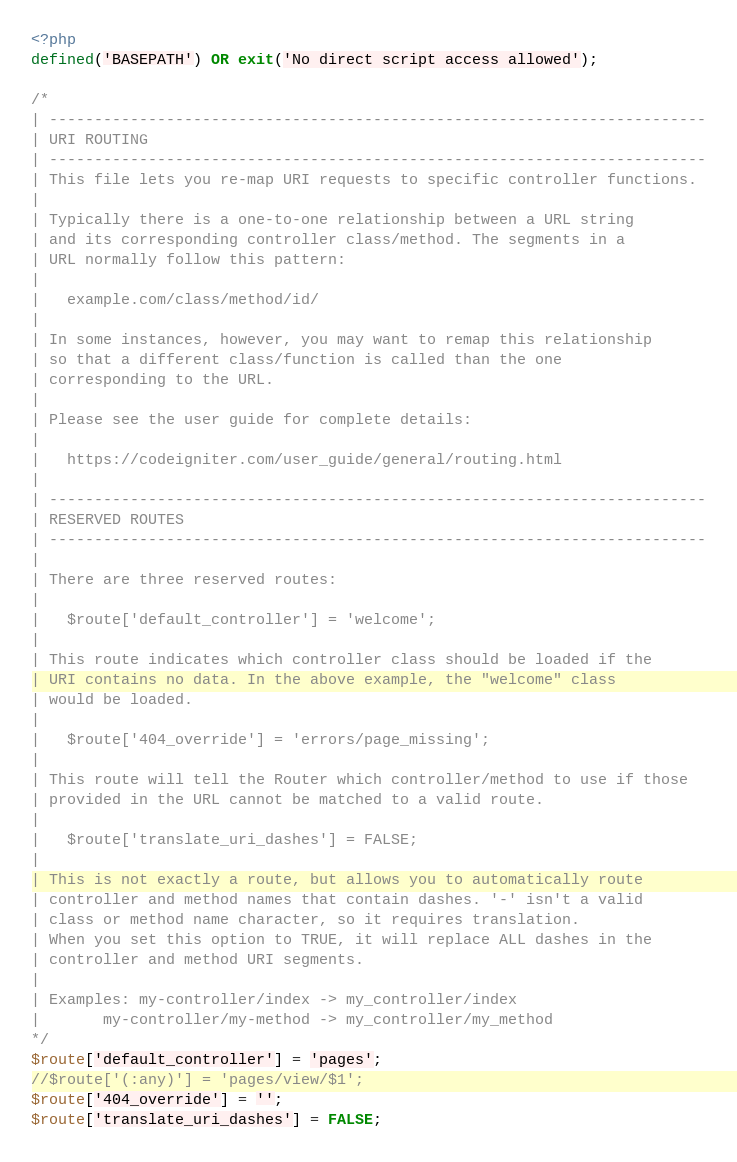Convert code to text. <code><loc_0><loc_0><loc_500><loc_500><_PHP_><?php
defined('BASEPATH') OR exit('No direct script access allowed');

/*
| -------------------------------------------------------------------------
| URI ROUTING
| -------------------------------------------------------------------------
| This file lets you re-map URI requests to specific controller functions.
|
| Typically there is a one-to-one relationship between a URL string
| and its corresponding controller class/method. The segments in a
| URL normally follow this pattern:
|
|	example.com/class/method/id/
|
| In some instances, however, you may want to remap this relationship
| so that a different class/function is called than the one
| corresponding to the URL.
|
| Please see the user guide for complete details:
|
|	https://codeigniter.com/user_guide/general/routing.html
|
| -------------------------------------------------------------------------
| RESERVED ROUTES
| -------------------------------------------------------------------------
|
| There are three reserved routes:
|
|	$route['default_controller'] = 'welcome';
|
| This route indicates which controller class should be loaded if the
| URI contains no data. In the above example, the "welcome" class
| would be loaded.
|
|	$route['404_override'] = 'errors/page_missing';
|
| This route will tell the Router which controller/method to use if those
| provided in the URL cannot be matched to a valid route.
|
|	$route['translate_uri_dashes'] = FALSE;
|
| This is not exactly a route, but allows you to automatically route
| controller and method names that contain dashes. '-' isn't a valid
| class or method name character, so it requires translation.
| When you set this option to TRUE, it will replace ALL dashes in the
| controller and method URI segments.
|
| Examples:	my-controller/index	-> my_controller/index
|		my-controller/my-method	-> my_controller/my_method
*/
$route['default_controller'] = 'pages';
//$route['(:any)'] = 'pages/view/$1';
$route['404_override'] = '';
$route['translate_uri_dashes'] = FALSE;
</code> 